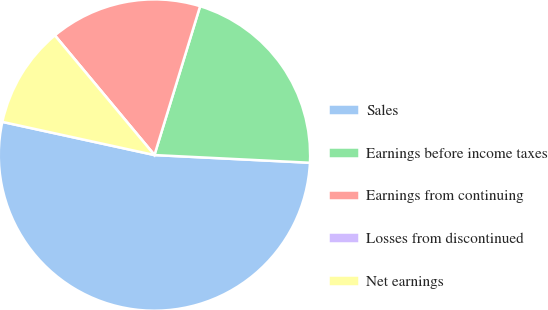Convert chart. <chart><loc_0><loc_0><loc_500><loc_500><pie_chart><fcel>Sales<fcel>Earnings before income taxes<fcel>Earnings from continuing<fcel>Losses from discontinued<fcel>Net earnings<nl><fcel>52.63%<fcel>21.05%<fcel>15.79%<fcel>0.0%<fcel>10.53%<nl></chart> 